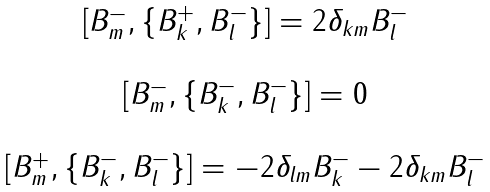<formula> <loc_0><loc_0><loc_500><loc_500>\begin{array} { c } \left [ B _ { m } ^ { - } , \{ B _ { k } ^ { + } , B _ { l } ^ { - } \} \right ] = 2 \delta _ { k m } B _ { l } ^ { - } \\ \\ \left [ B _ { m } ^ { - } , \{ B _ { k } ^ { - } , B _ { l } ^ { - } \} \right ] = 0 \\ \\ \left [ B _ { m } ^ { + } , \{ B _ { k } ^ { - } , B _ { l } ^ { - } \} \right ] = - 2 \delta _ { l m } B _ { k } ^ { - } - 2 \delta _ { k m } B _ { l } ^ { - } \\ \end{array}</formula> 